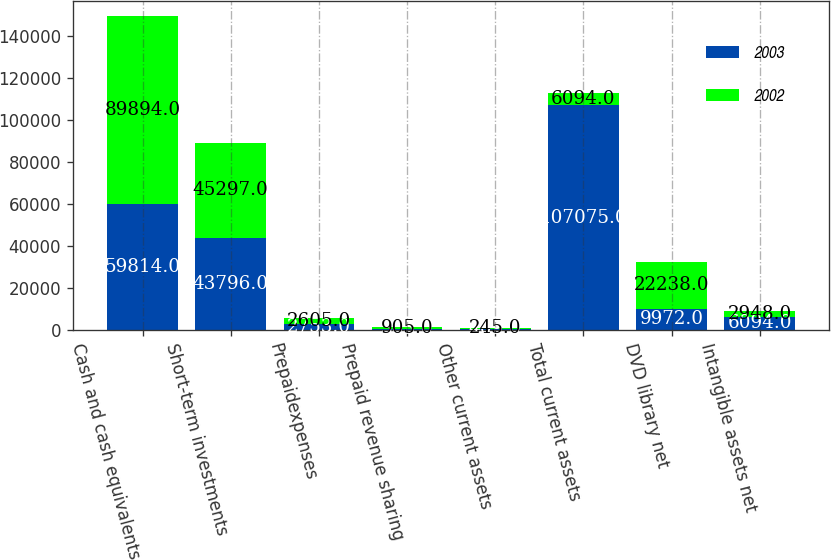Convert chart. <chart><loc_0><loc_0><loc_500><loc_500><stacked_bar_chart><ecel><fcel>Cash and cash equivalents<fcel>Short-term investments<fcel>Prepaidexpenses<fcel>Prepaid revenue sharing<fcel>Other current assets<fcel>Total current assets<fcel>DVD library net<fcel>Intangible assets net<nl><fcel>2003<fcel>59814<fcel>43796<fcel>2753<fcel>303<fcel>409<fcel>107075<fcel>9972<fcel>6094<nl><fcel>2002<fcel>89894<fcel>45297<fcel>2605<fcel>905<fcel>245<fcel>6094<fcel>22238<fcel>2948<nl></chart> 